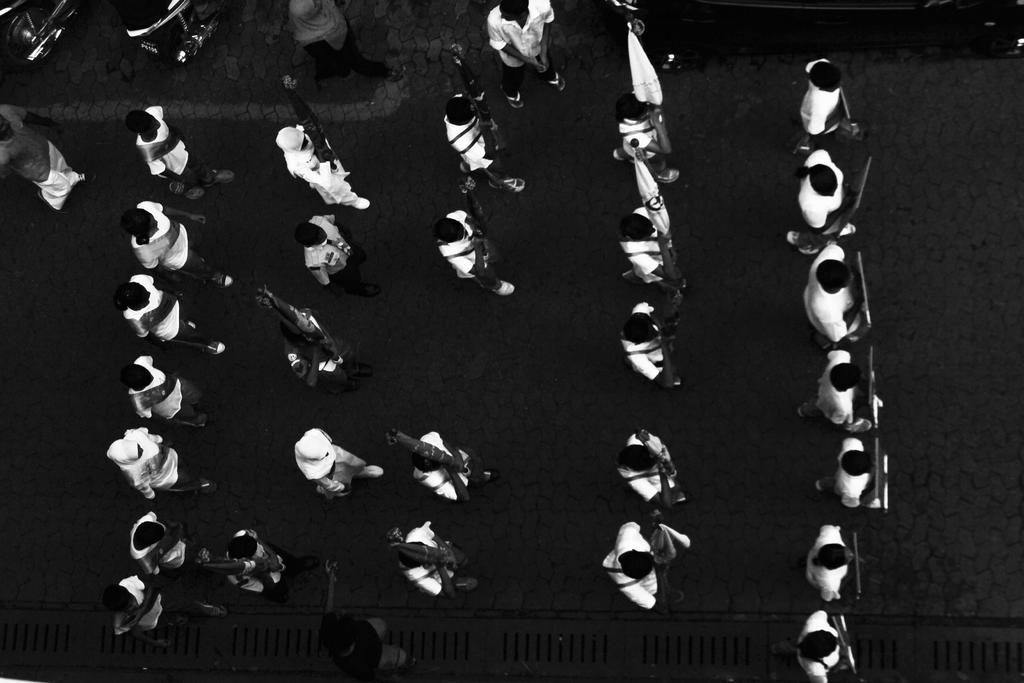Who or what can be seen in the image? There are people in the image. What are the people doing in the image? The people are walking on the road. What are the people holding in the image? The people are holding placards and flags. What type of tray can be seen being carried by the doctor in the image? There is no doctor or tray present in the image. How many trees are visible in the image? There are no trees visible in the image; it features people walking on the road while holding placards and flags. 